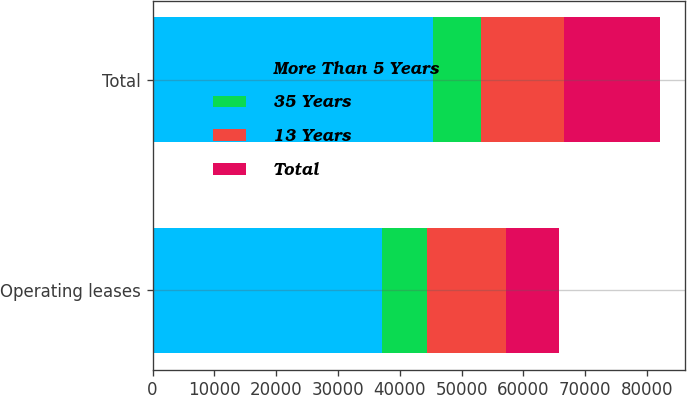Convert chart to OTSL. <chart><loc_0><loc_0><loc_500><loc_500><stacked_bar_chart><ecel><fcel>Operating leases<fcel>Total<nl><fcel>More Than 5 Years<fcel>37148<fcel>45343<nl><fcel>35 Years<fcel>7233<fcel>7812<nl><fcel>13 Years<fcel>12849<fcel>13425<nl><fcel>Total<fcel>8479<fcel>15519<nl></chart> 